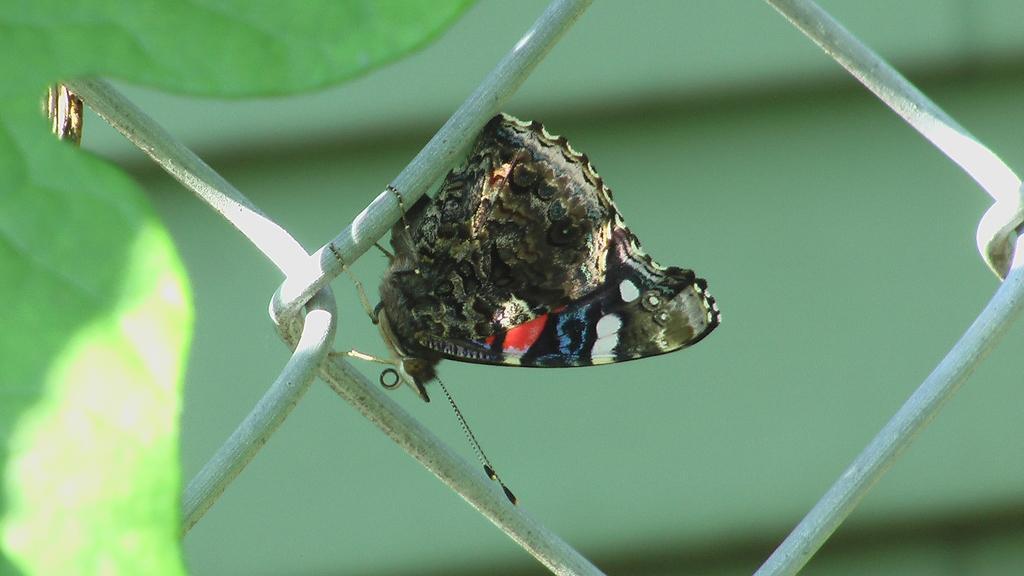In one or two sentences, can you explain what this image depicts? In the center of the image we can see a butterfly on the fence. On the left there is a leaf. 